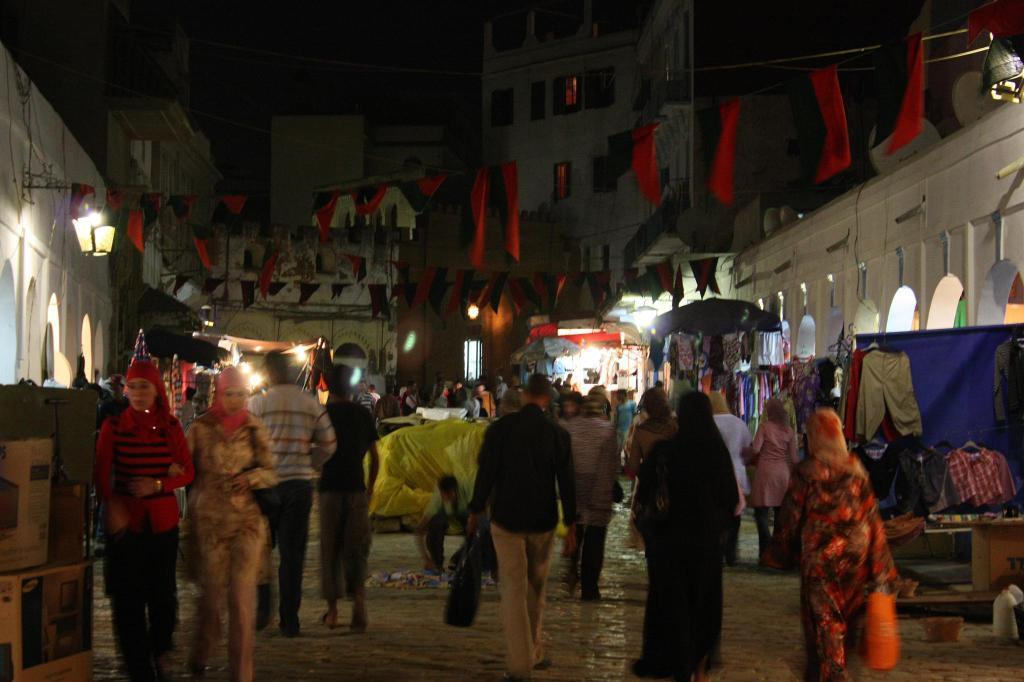Please provide a concise description of this image. In this picture we can see a group of people walking on the path and on the path there are cardboard boxes, clothes and other things. Behind the people there are buildings with lights and some decorative items. 